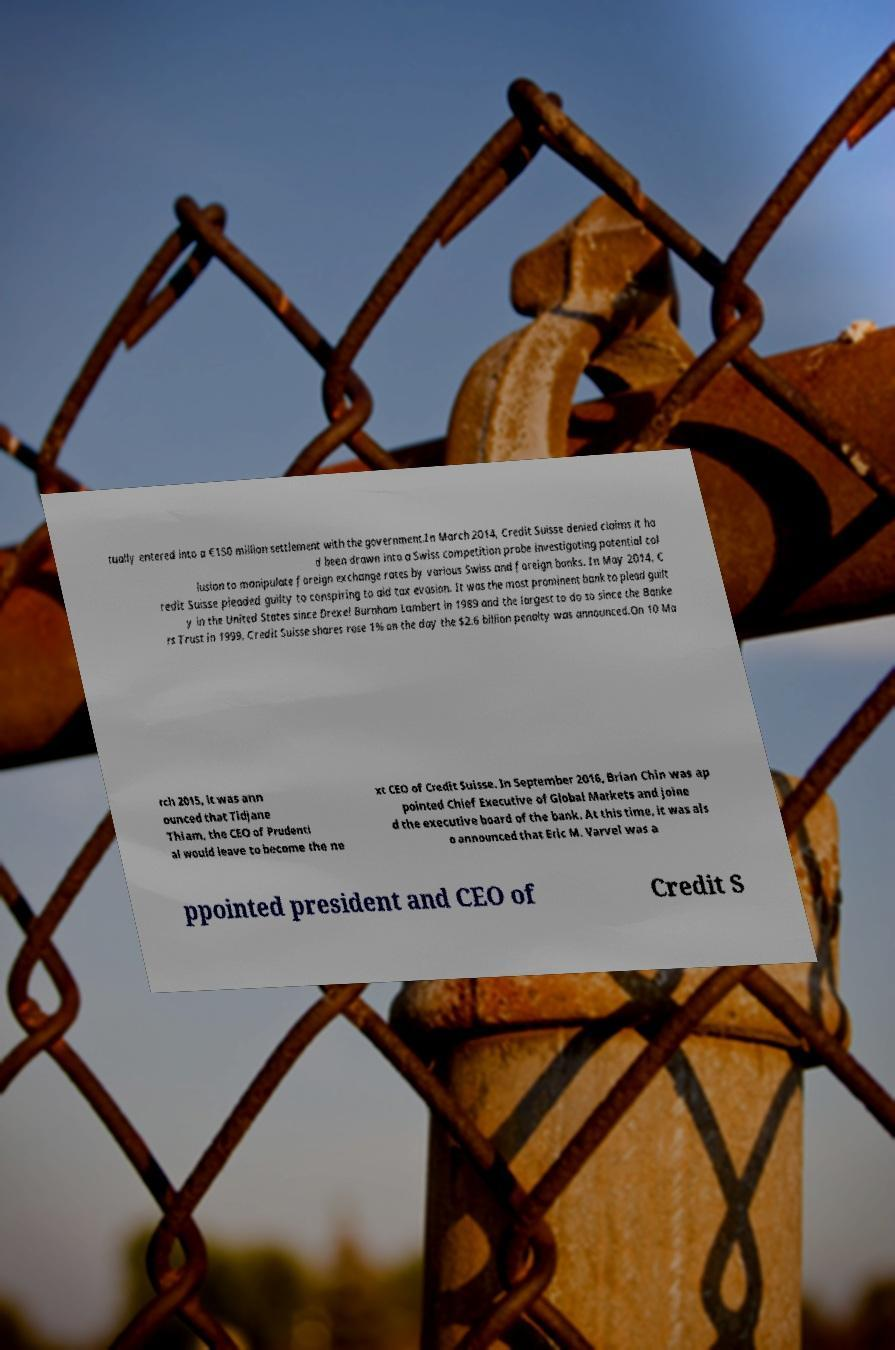Can you accurately transcribe the text from the provided image for me? tually entered into a €150 million settlement with the government.In March 2014, Credit Suisse denied claims it ha d been drawn into a Swiss competition probe investigating potential col lusion to manipulate foreign exchange rates by various Swiss and foreign banks. In May 2014, C redit Suisse pleaded guilty to conspiring to aid tax evasion. It was the most prominent bank to plead guilt y in the United States since Drexel Burnham Lambert in 1989 and the largest to do so since the Banke rs Trust in 1999. Credit Suisse shares rose 1% on the day the $2.6 billion penalty was announced.On 10 Ma rch 2015, it was ann ounced that Tidjane Thiam, the CEO of Prudenti al would leave to become the ne xt CEO of Credit Suisse. In September 2016, Brian Chin was ap pointed Chief Executive of Global Markets and joine d the executive board of the bank. At this time, it was als o announced that Eric M. Varvel was a ppointed president and CEO of Credit S 